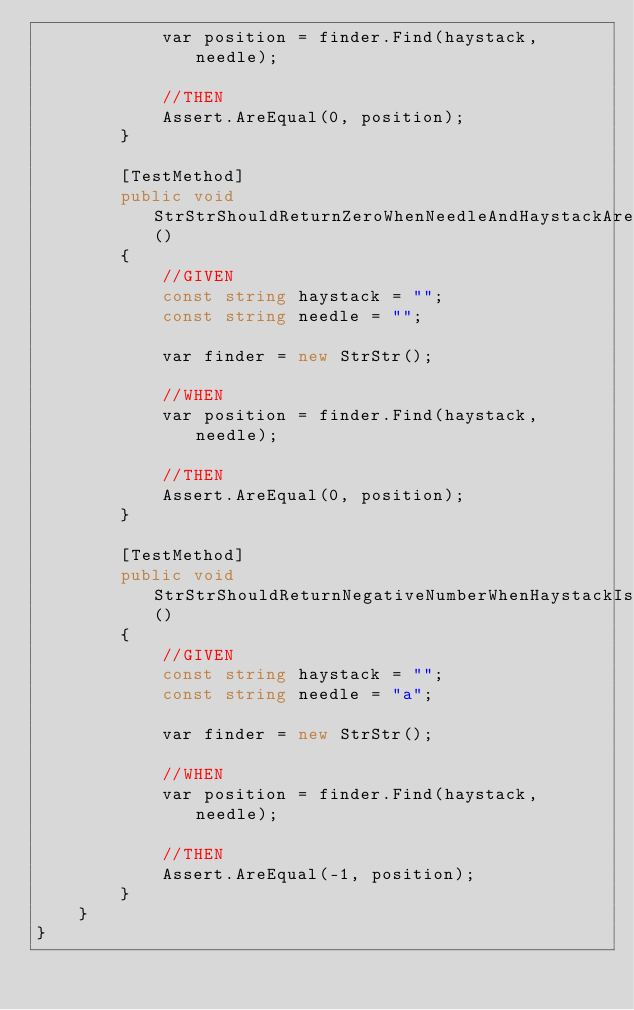Convert code to text. <code><loc_0><loc_0><loc_500><loc_500><_C#_>            var position = finder.Find(haystack, needle);

            //THEN
            Assert.AreEqual(0, position);
        }

        [TestMethod]
        public void StrStrShouldReturnZeroWhenNeedleAndHaystackAreAnEmptyStrings()
        {
            //GIVEN
            const string haystack = "";
            const string needle = "";

            var finder = new StrStr();

            //WHEN
            var position = finder.Find(haystack, needle);

            //THEN
            Assert.AreEqual(0, position);
        }

        [TestMethod]
        public void StrStrShouldReturnNegativeNumberWhenHaystackIsEmptyButNeedleIsNot()
        {
            //GIVEN
            const string haystack = "";
            const string needle = "a";

            var finder = new StrStr();

            //WHEN
            var position = finder.Find(haystack, needle);

            //THEN
            Assert.AreEqual(-1, position);
        }
    }
}</code> 